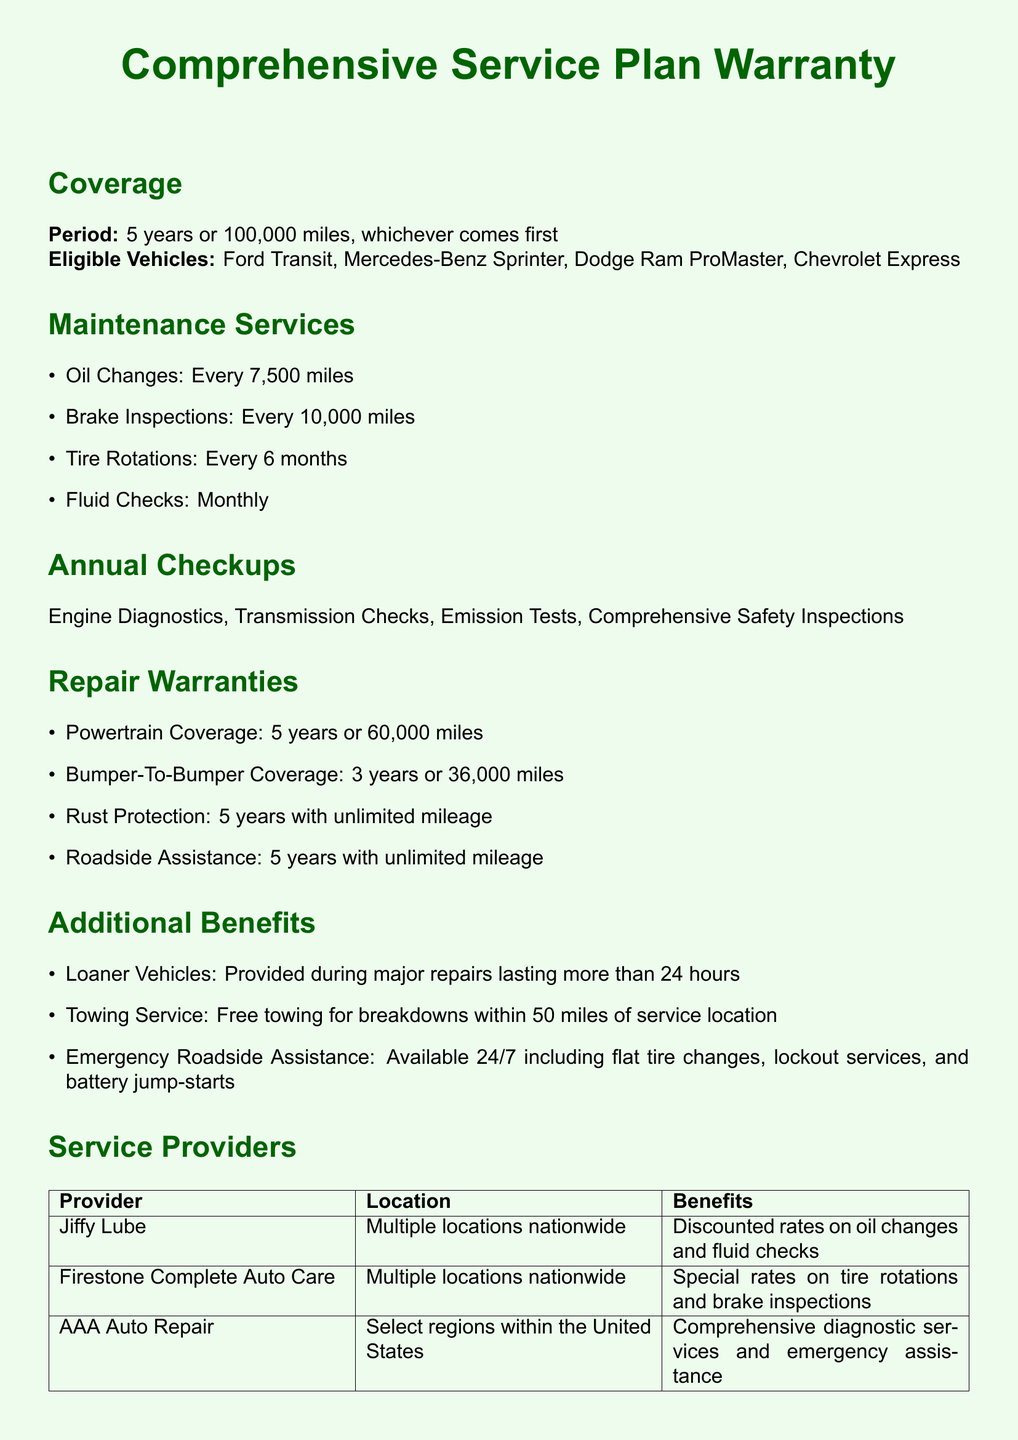What is the coverage period? The coverage period is stated in the document, which indicates the time frame for the warranty coverage.
Answer: 5 years or 100,000 miles What types of vehicles are eligible? The document lists specific vehicle models that are eligible for the warranty service plan.
Answer: Ford Transit, Mercedes-Benz Sprinter, Dodge Ram ProMaster, Chevrolet Express How often are oil changes required? The document specifies the frequency of oil changes as part of the maintenance services.
Answer: Every 7,500 miles What is included in powertrain coverage? The warranty document outlines specific types of coverage, and powertrain coverage is one of them.
Answer: 5 years or 60,000 miles How long is the bumper-to-bumper coverage? The warranty document details the duration of different types of repair warranties, including bumper-to-bumper coverage.
Answer: 3 years or 36,000 miles Which service provider offers discounted oil changes? The document lists different service providers along with the benefits they offer.
Answer: Jiffy Lube What type of assistance is available 24/7? The document specifies the types of emergency assistance that are available around the clock.
Answer: Emergency Roadside Assistance What is the free towing distance for breakdowns? The information about towing services in the document specifies a limit for free towing.
Answer: 50 miles How can I contact the warranty service center? The document provides specific contact details for the warranty service center.
Answer: 1-800-123-4567, service@vansupport.org 